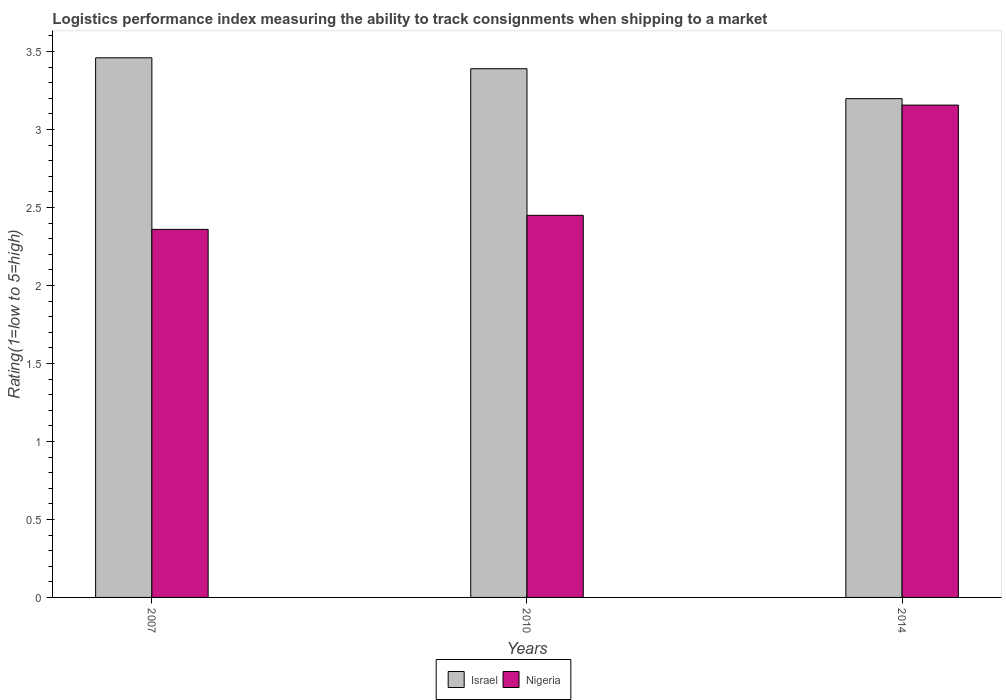How many different coloured bars are there?
Make the answer very short. 2. How many groups of bars are there?
Keep it short and to the point. 3. Are the number of bars per tick equal to the number of legend labels?
Offer a very short reply. Yes. Are the number of bars on each tick of the X-axis equal?
Keep it short and to the point. Yes. How many bars are there on the 3rd tick from the right?
Provide a short and direct response. 2. What is the label of the 2nd group of bars from the left?
Provide a succinct answer. 2010. What is the Logistic performance index in Nigeria in 2007?
Your response must be concise. 2.36. Across all years, what is the maximum Logistic performance index in Israel?
Offer a terse response. 3.46. Across all years, what is the minimum Logistic performance index in Nigeria?
Ensure brevity in your answer.  2.36. In which year was the Logistic performance index in Nigeria maximum?
Your answer should be compact. 2014. In which year was the Logistic performance index in Israel minimum?
Your answer should be compact. 2014. What is the total Logistic performance index in Nigeria in the graph?
Ensure brevity in your answer.  7.97. What is the difference between the Logistic performance index in Israel in 2007 and that in 2010?
Provide a succinct answer. 0.07. What is the difference between the Logistic performance index in Israel in 2007 and the Logistic performance index in Nigeria in 2010?
Your response must be concise. 1.01. What is the average Logistic performance index in Nigeria per year?
Provide a short and direct response. 2.66. In how many years, is the Logistic performance index in Nigeria greater than 2.9?
Keep it short and to the point. 1. What is the ratio of the Logistic performance index in Nigeria in 2007 to that in 2014?
Offer a terse response. 0.75. What is the difference between the highest and the second highest Logistic performance index in Nigeria?
Provide a succinct answer. 0.71. What is the difference between the highest and the lowest Logistic performance index in Nigeria?
Keep it short and to the point. 0.8. In how many years, is the Logistic performance index in Nigeria greater than the average Logistic performance index in Nigeria taken over all years?
Give a very brief answer. 1. What does the 2nd bar from the left in 2007 represents?
Your answer should be compact. Nigeria. What does the 1st bar from the right in 2007 represents?
Give a very brief answer. Nigeria. How many years are there in the graph?
Ensure brevity in your answer.  3. What is the difference between two consecutive major ticks on the Y-axis?
Give a very brief answer. 0.5. Does the graph contain any zero values?
Provide a succinct answer. No. What is the title of the graph?
Your answer should be compact. Logistics performance index measuring the ability to track consignments when shipping to a market. What is the label or title of the X-axis?
Offer a terse response. Years. What is the label or title of the Y-axis?
Your answer should be compact. Rating(1=low to 5=high). What is the Rating(1=low to 5=high) of Israel in 2007?
Make the answer very short. 3.46. What is the Rating(1=low to 5=high) in Nigeria in 2007?
Offer a terse response. 2.36. What is the Rating(1=low to 5=high) in Israel in 2010?
Ensure brevity in your answer.  3.39. What is the Rating(1=low to 5=high) of Nigeria in 2010?
Provide a short and direct response. 2.45. What is the Rating(1=low to 5=high) of Israel in 2014?
Provide a succinct answer. 3.2. What is the Rating(1=low to 5=high) in Nigeria in 2014?
Make the answer very short. 3.16. Across all years, what is the maximum Rating(1=low to 5=high) in Israel?
Offer a very short reply. 3.46. Across all years, what is the maximum Rating(1=low to 5=high) in Nigeria?
Your response must be concise. 3.16. Across all years, what is the minimum Rating(1=low to 5=high) in Israel?
Provide a succinct answer. 3.2. Across all years, what is the minimum Rating(1=low to 5=high) in Nigeria?
Make the answer very short. 2.36. What is the total Rating(1=low to 5=high) of Israel in the graph?
Offer a terse response. 10.05. What is the total Rating(1=low to 5=high) of Nigeria in the graph?
Give a very brief answer. 7.97. What is the difference between the Rating(1=low to 5=high) of Israel in 2007 and that in 2010?
Your answer should be compact. 0.07. What is the difference between the Rating(1=low to 5=high) in Nigeria in 2007 and that in 2010?
Your answer should be compact. -0.09. What is the difference between the Rating(1=low to 5=high) in Israel in 2007 and that in 2014?
Your answer should be compact. 0.26. What is the difference between the Rating(1=low to 5=high) of Nigeria in 2007 and that in 2014?
Provide a short and direct response. -0.8. What is the difference between the Rating(1=low to 5=high) in Israel in 2010 and that in 2014?
Give a very brief answer. 0.19. What is the difference between the Rating(1=low to 5=high) in Nigeria in 2010 and that in 2014?
Your answer should be compact. -0.71. What is the difference between the Rating(1=low to 5=high) of Israel in 2007 and the Rating(1=low to 5=high) of Nigeria in 2014?
Offer a terse response. 0.3. What is the difference between the Rating(1=low to 5=high) of Israel in 2010 and the Rating(1=low to 5=high) of Nigeria in 2014?
Your answer should be compact. 0.23. What is the average Rating(1=low to 5=high) of Israel per year?
Offer a terse response. 3.35. What is the average Rating(1=low to 5=high) in Nigeria per year?
Keep it short and to the point. 2.66. In the year 2007, what is the difference between the Rating(1=low to 5=high) of Israel and Rating(1=low to 5=high) of Nigeria?
Offer a very short reply. 1.1. In the year 2010, what is the difference between the Rating(1=low to 5=high) in Israel and Rating(1=low to 5=high) in Nigeria?
Your response must be concise. 0.94. In the year 2014, what is the difference between the Rating(1=low to 5=high) in Israel and Rating(1=low to 5=high) in Nigeria?
Your answer should be compact. 0.04. What is the ratio of the Rating(1=low to 5=high) of Israel in 2007 to that in 2010?
Your answer should be very brief. 1.02. What is the ratio of the Rating(1=low to 5=high) in Nigeria in 2007 to that in 2010?
Provide a short and direct response. 0.96. What is the ratio of the Rating(1=low to 5=high) in Israel in 2007 to that in 2014?
Your response must be concise. 1.08. What is the ratio of the Rating(1=low to 5=high) of Nigeria in 2007 to that in 2014?
Provide a succinct answer. 0.75. What is the ratio of the Rating(1=low to 5=high) of Israel in 2010 to that in 2014?
Your response must be concise. 1.06. What is the ratio of the Rating(1=low to 5=high) of Nigeria in 2010 to that in 2014?
Ensure brevity in your answer.  0.78. What is the difference between the highest and the second highest Rating(1=low to 5=high) of Israel?
Keep it short and to the point. 0.07. What is the difference between the highest and the second highest Rating(1=low to 5=high) in Nigeria?
Provide a short and direct response. 0.71. What is the difference between the highest and the lowest Rating(1=low to 5=high) of Israel?
Offer a very short reply. 0.26. What is the difference between the highest and the lowest Rating(1=low to 5=high) of Nigeria?
Offer a terse response. 0.8. 